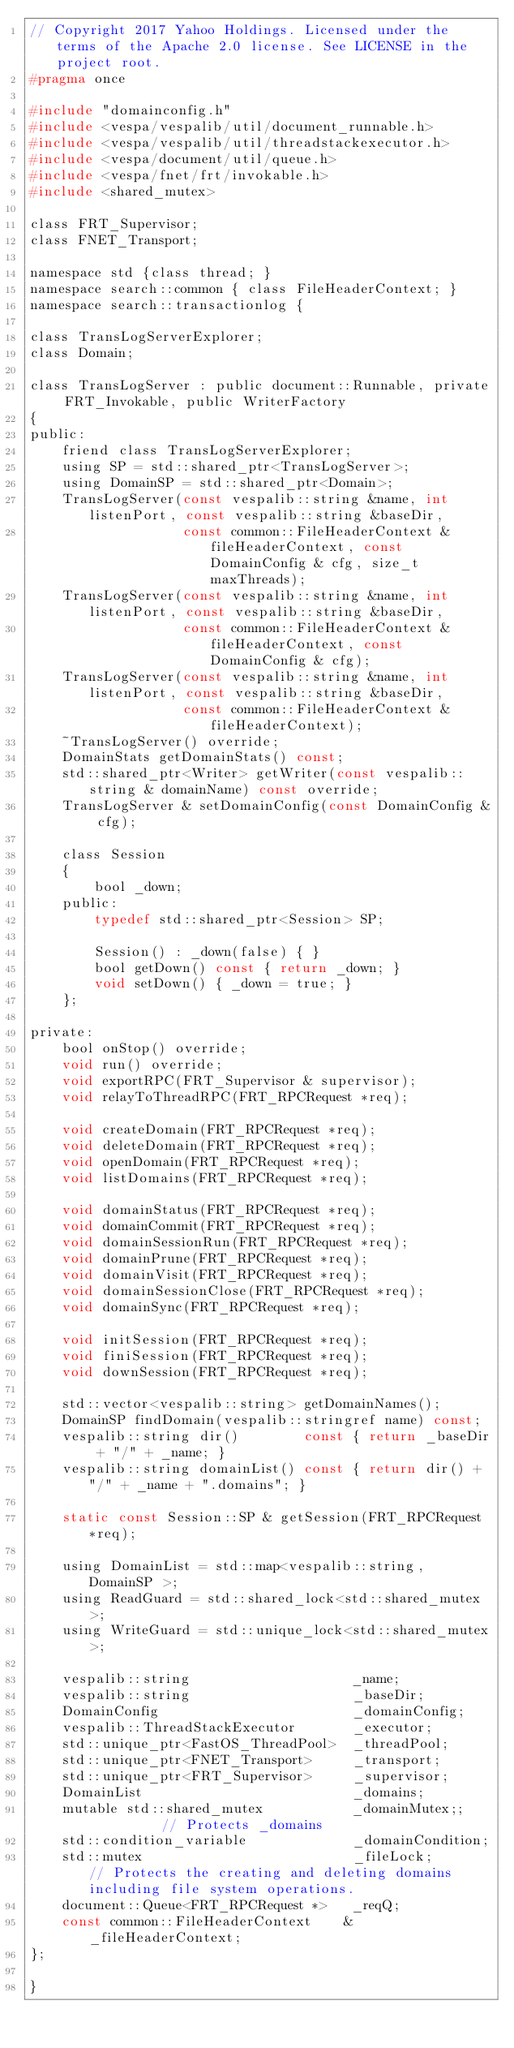<code> <loc_0><loc_0><loc_500><loc_500><_C_>// Copyright 2017 Yahoo Holdings. Licensed under the terms of the Apache 2.0 license. See LICENSE in the project root.
#pragma once

#include "domainconfig.h"
#include <vespa/vespalib/util/document_runnable.h>
#include <vespa/vespalib/util/threadstackexecutor.h>
#include <vespa/document/util/queue.h>
#include <vespa/fnet/frt/invokable.h>
#include <shared_mutex>

class FRT_Supervisor;
class FNET_Transport;

namespace std {class thread; }
namespace search::common { class FileHeaderContext; }
namespace search::transactionlog {

class TransLogServerExplorer;
class Domain;

class TransLogServer : public document::Runnable, private FRT_Invokable, public WriterFactory
{
public:
    friend class TransLogServerExplorer;
    using SP = std::shared_ptr<TransLogServer>;
    using DomainSP = std::shared_ptr<Domain>;
    TransLogServer(const vespalib::string &name, int listenPort, const vespalib::string &baseDir,
                   const common::FileHeaderContext &fileHeaderContext, const DomainConfig & cfg, size_t maxThreads);
    TransLogServer(const vespalib::string &name, int listenPort, const vespalib::string &baseDir,
                   const common::FileHeaderContext &fileHeaderContext, const DomainConfig & cfg);
    TransLogServer(const vespalib::string &name, int listenPort, const vespalib::string &baseDir,
                   const common::FileHeaderContext &fileHeaderContext);
    ~TransLogServer() override;
    DomainStats getDomainStats() const;
    std::shared_ptr<Writer> getWriter(const vespalib::string & domainName) const override;
    TransLogServer & setDomainConfig(const DomainConfig & cfg);

    class Session
    {
        bool _down;
    public:
        typedef std::shared_ptr<Session> SP;

        Session() : _down(false) { }
        bool getDown() const { return _down; }
        void setDown() { _down = true; }
    };

private:
    bool onStop() override;
    void run() override;
    void exportRPC(FRT_Supervisor & supervisor);
    void relayToThreadRPC(FRT_RPCRequest *req);

    void createDomain(FRT_RPCRequest *req);
    void deleteDomain(FRT_RPCRequest *req);
    void openDomain(FRT_RPCRequest *req);
    void listDomains(FRT_RPCRequest *req);

    void domainStatus(FRT_RPCRequest *req);
    void domainCommit(FRT_RPCRequest *req);
    void domainSessionRun(FRT_RPCRequest *req);
    void domainPrune(FRT_RPCRequest *req);
    void domainVisit(FRT_RPCRequest *req);
    void domainSessionClose(FRT_RPCRequest *req);
    void domainSync(FRT_RPCRequest *req);

    void initSession(FRT_RPCRequest *req);
    void finiSession(FRT_RPCRequest *req);
    void downSession(FRT_RPCRequest *req);

    std::vector<vespalib::string> getDomainNames();
    DomainSP findDomain(vespalib::stringref name) const;
    vespalib::string dir()        const { return _baseDir + "/" + _name; }
    vespalib::string domainList() const { return dir() + "/" + _name + ".domains"; }

    static const Session::SP & getSession(FRT_RPCRequest *req);

    using DomainList = std::map<vespalib::string, DomainSP >;
    using ReadGuard = std::shared_lock<std::shared_mutex>;
    using WriteGuard = std::unique_lock<std::shared_mutex>;

    vespalib::string                    _name;
    vespalib::string                    _baseDir;
    DomainConfig                        _domainConfig;
    vespalib::ThreadStackExecutor       _executor;
    std::unique_ptr<FastOS_ThreadPool>  _threadPool;
    std::unique_ptr<FNET_Transport>     _transport;
    std::unique_ptr<FRT_Supervisor>     _supervisor;
    DomainList                          _domains;
    mutable std::shared_mutex           _domainMutex;;          // Protects _domains
    std::condition_variable             _domainCondition;
    std::mutex                          _fileLock;      // Protects the creating and deleting domains including file system operations.
    document::Queue<FRT_RPCRequest *>   _reqQ;
    const common::FileHeaderContext    &_fileHeaderContext;
};

}
</code> 